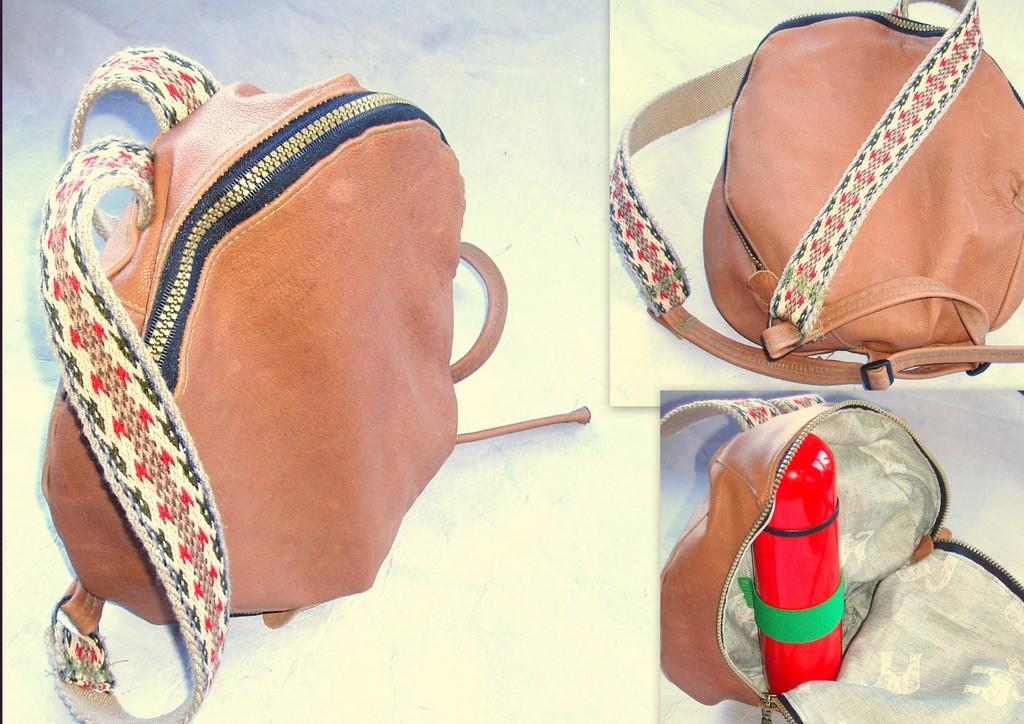Please provide a concise description of this image. This image is a collage image of a bag. On the bottom right side of the image there is a bottle in the bag. 